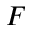Convert formula to latex. <formula><loc_0><loc_0><loc_500><loc_500>F</formula> 